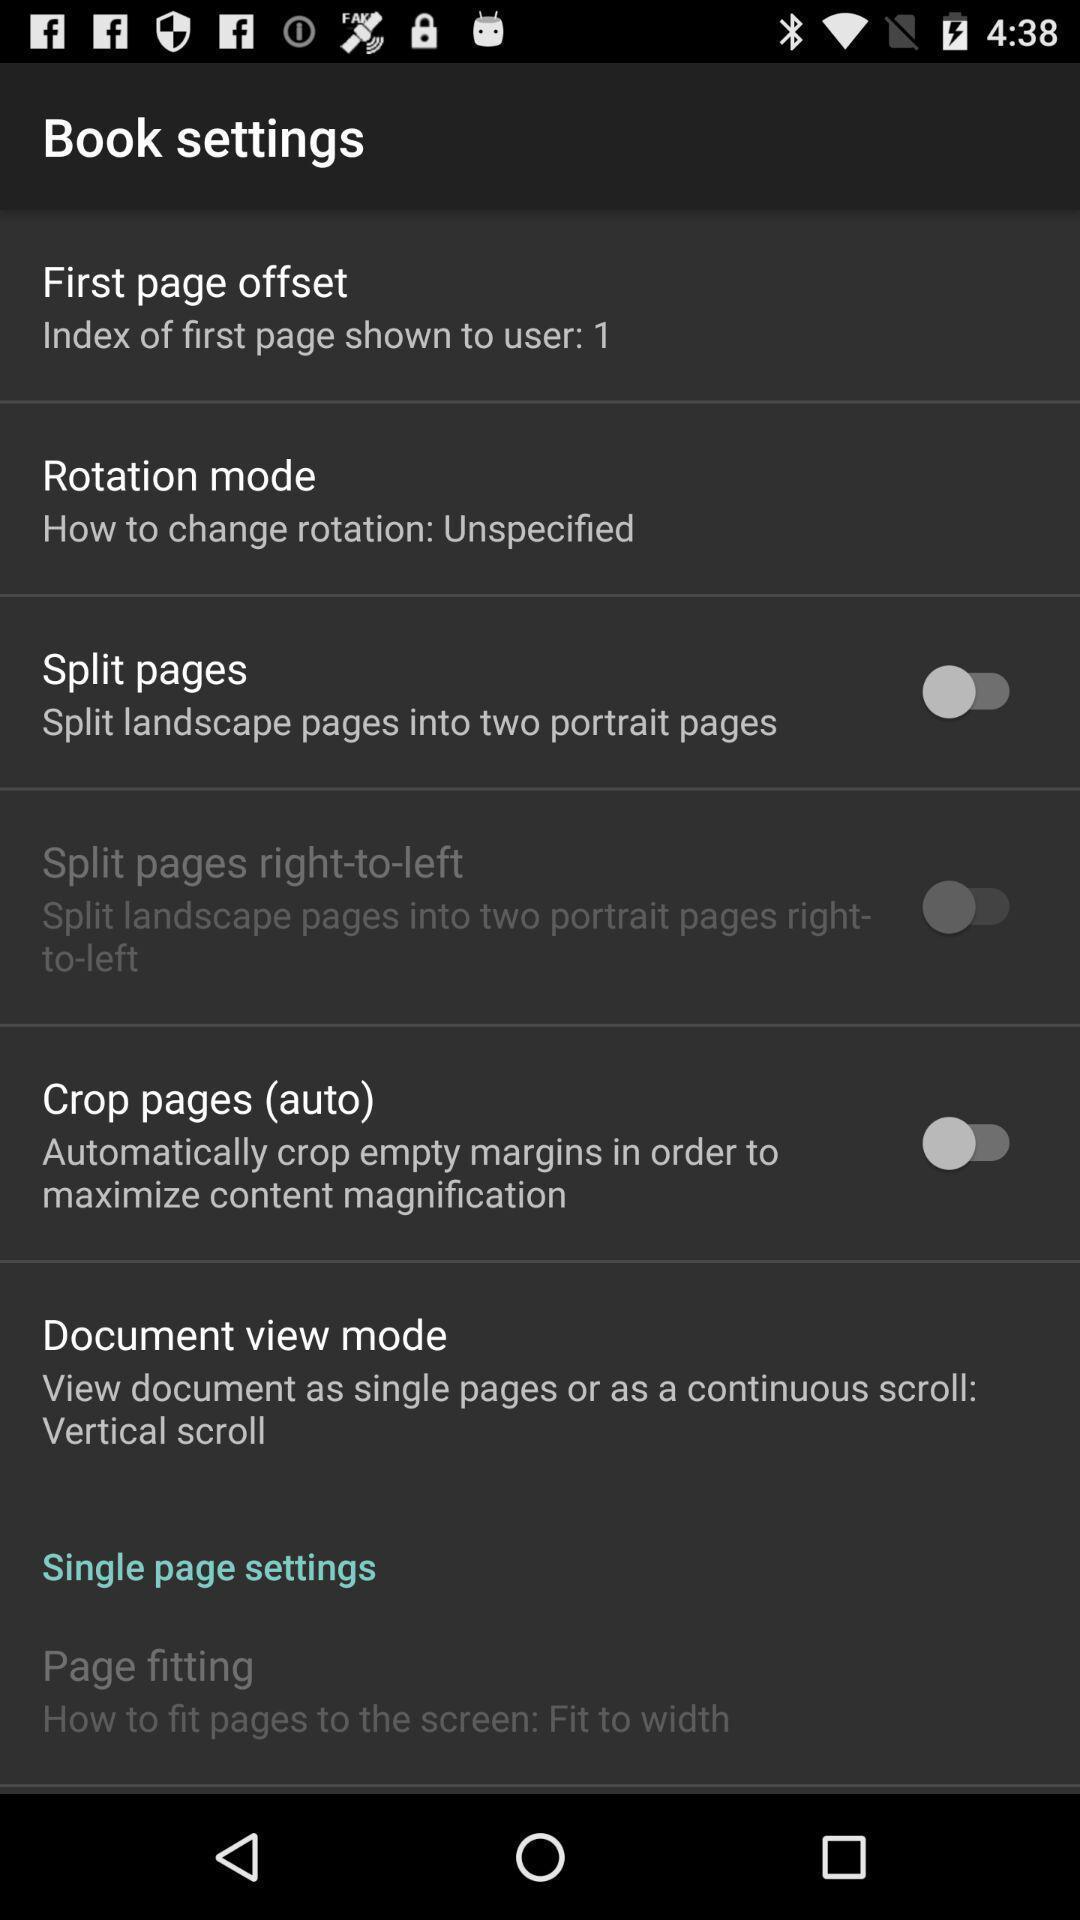Give me a summary of this screen capture. Screen shows book settings list in a reading app. 